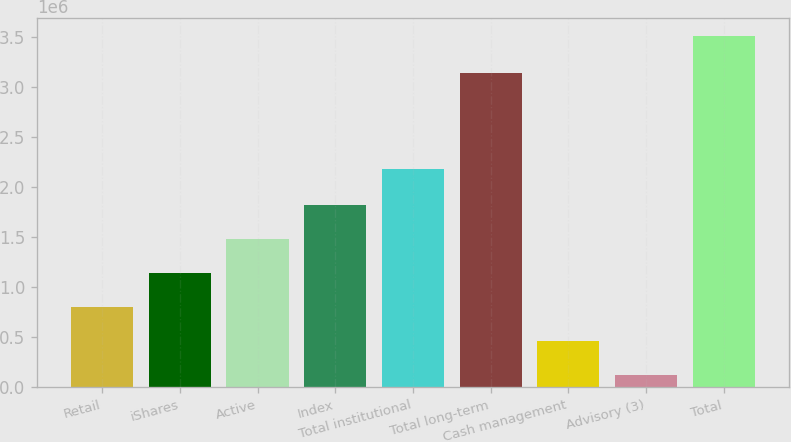Convert chart to OTSL. <chart><loc_0><loc_0><loc_500><loc_500><bar_chart><fcel>Retail<fcel>iShares<fcel>Active<fcel>Index<fcel>Total institutional<fcel>Total long-term<fcel>Cash management<fcel>Advisory (3)<fcel>Total<nl><fcel>798592<fcel>1.13785e+06<fcel>1.47711e+06<fcel>1.81638e+06<fcel>2.18123e+06<fcel>3.13795e+06<fcel>459331<fcel>120070<fcel>3.51268e+06<nl></chart> 